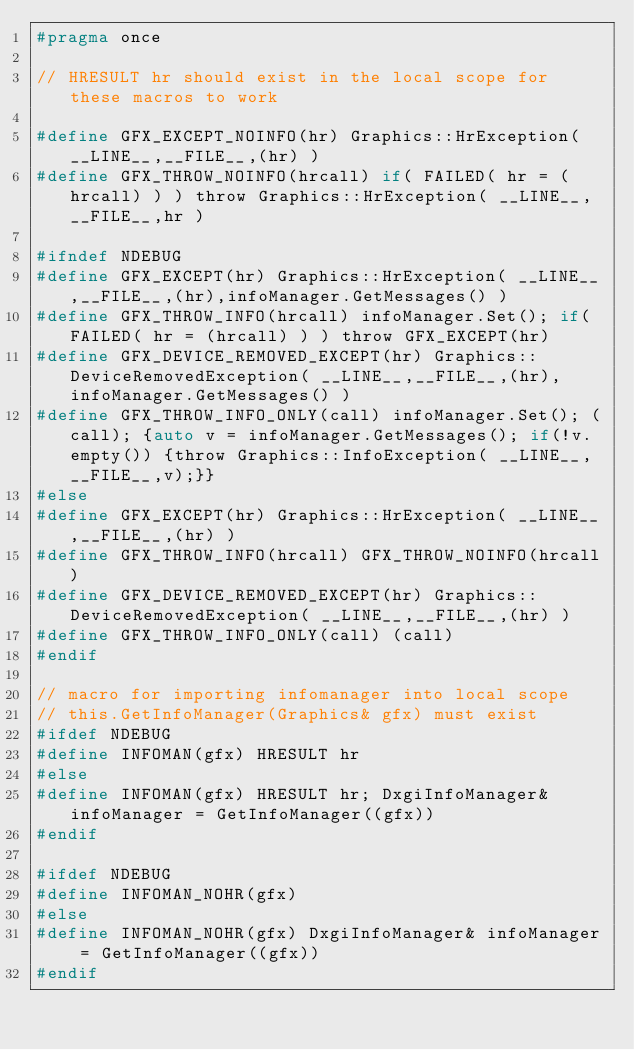<code> <loc_0><loc_0><loc_500><loc_500><_C_>#pragma once

// HRESULT hr should exist in the local scope for these macros to work

#define GFX_EXCEPT_NOINFO(hr) Graphics::HrException( __LINE__,__FILE__,(hr) )
#define GFX_THROW_NOINFO(hrcall) if( FAILED( hr = (hrcall) ) ) throw Graphics::HrException( __LINE__,__FILE__,hr )

#ifndef NDEBUG
#define GFX_EXCEPT(hr) Graphics::HrException( __LINE__,__FILE__,(hr),infoManager.GetMessages() )
#define GFX_THROW_INFO(hrcall) infoManager.Set(); if( FAILED( hr = (hrcall) ) ) throw GFX_EXCEPT(hr)
#define GFX_DEVICE_REMOVED_EXCEPT(hr) Graphics::DeviceRemovedException( __LINE__,__FILE__,(hr),infoManager.GetMessages() )
#define GFX_THROW_INFO_ONLY(call) infoManager.Set(); (call); {auto v = infoManager.GetMessages(); if(!v.empty()) {throw Graphics::InfoException( __LINE__,__FILE__,v);}}
#else
#define GFX_EXCEPT(hr) Graphics::HrException( __LINE__,__FILE__,(hr) )
#define GFX_THROW_INFO(hrcall) GFX_THROW_NOINFO(hrcall)
#define GFX_DEVICE_REMOVED_EXCEPT(hr) Graphics::DeviceRemovedException( __LINE__,__FILE__,(hr) )
#define GFX_THROW_INFO_ONLY(call) (call)
#endif

// macro for importing infomanager into local scope
// this.GetInfoManager(Graphics& gfx) must exist
#ifdef NDEBUG
#define INFOMAN(gfx) HRESULT hr
#else
#define INFOMAN(gfx) HRESULT hr; DxgiInfoManager& infoManager = GetInfoManager((gfx))
#endif

#ifdef NDEBUG
#define INFOMAN_NOHR(gfx)
#else
#define INFOMAN_NOHR(gfx) DxgiInfoManager& infoManager = GetInfoManager((gfx))
#endif</code> 